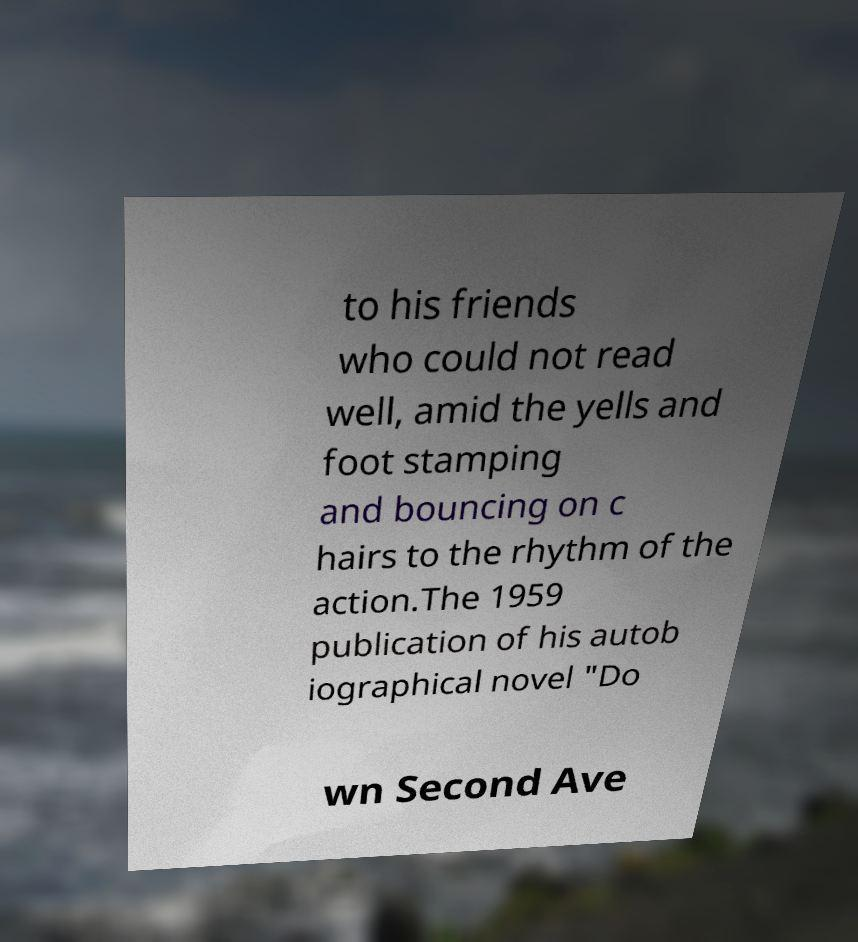There's text embedded in this image that I need extracted. Can you transcribe it verbatim? to his friends who could not read well, amid the yells and foot stamping and bouncing on c hairs to the rhythm of the action.The 1959 publication of his autob iographical novel "Do wn Second Ave 